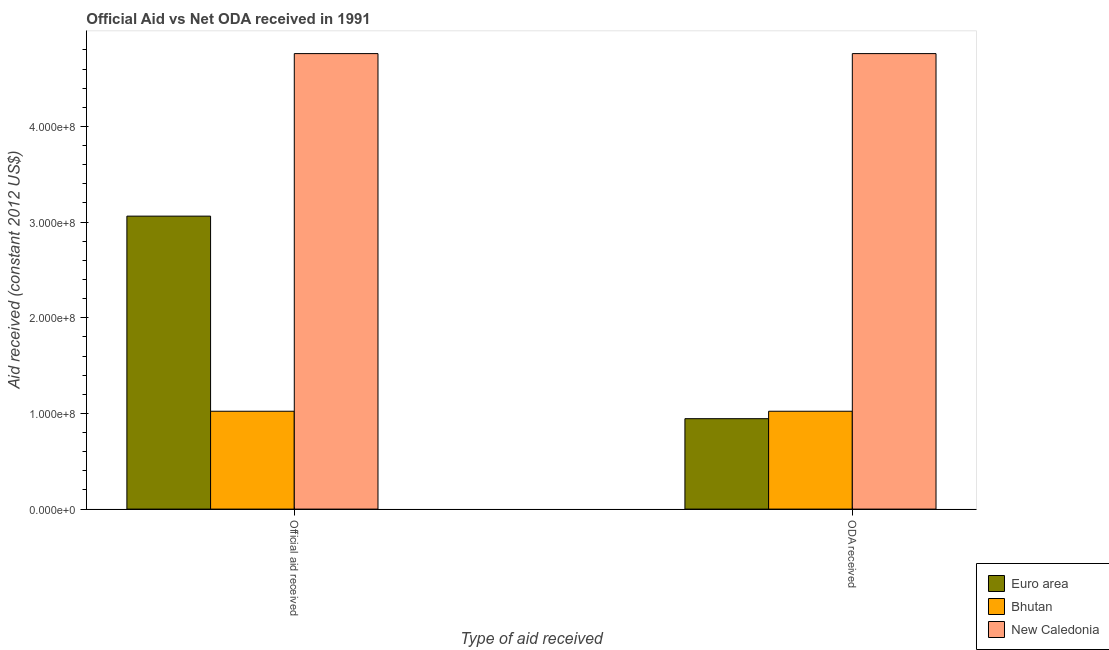How many different coloured bars are there?
Make the answer very short. 3. Are the number of bars on each tick of the X-axis equal?
Ensure brevity in your answer.  Yes. How many bars are there on the 1st tick from the left?
Your answer should be compact. 3. How many bars are there on the 2nd tick from the right?
Your answer should be very brief. 3. What is the label of the 1st group of bars from the left?
Your response must be concise. Official aid received. What is the official aid received in Bhutan?
Provide a short and direct response. 1.02e+08. Across all countries, what is the maximum oda received?
Your answer should be compact. 4.76e+08. Across all countries, what is the minimum oda received?
Keep it short and to the point. 9.45e+07. In which country was the official aid received maximum?
Give a very brief answer. New Caledonia. In which country was the official aid received minimum?
Ensure brevity in your answer.  Bhutan. What is the total oda received in the graph?
Your response must be concise. 6.73e+08. What is the difference between the oda received in New Caledonia and that in Euro area?
Offer a very short reply. 3.82e+08. What is the difference between the official aid received in Bhutan and the oda received in Euro area?
Offer a very short reply. 7.78e+06. What is the average official aid received per country?
Your answer should be compact. 2.95e+08. What is the difference between the oda received and official aid received in New Caledonia?
Keep it short and to the point. 0. In how many countries, is the official aid received greater than 140000000 US$?
Offer a terse response. 2. What is the ratio of the oda received in Bhutan to that in New Caledonia?
Offer a very short reply. 0.21. Is the official aid received in Bhutan less than that in Euro area?
Your answer should be very brief. Yes. In how many countries, is the oda received greater than the average oda received taken over all countries?
Offer a terse response. 1. What does the 2nd bar from the left in Official aid received represents?
Your answer should be compact. Bhutan. What does the 1st bar from the right in ODA received represents?
Make the answer very short. New Caledonia. Are all the bars in the graph horizontal?
Your answer should be compact. No. Are the values on the major ticks of Y-axis written in scientific E-notation?
Provide a succinct answer. Yes. How many legend labels are there?
Your answer should be very brief. 3. How are the legend labels stacked?
Give a very brief answer. Vertical. What is the title of the graph?
Offer a very short reply. Official Aid vs Net ODA received in 1991 . Does "Curacao" appear as one of the legend labels in the graph?
Offer a very short reply. No. What is the label or title of the X-axis?
Provide a short and direct response. Type of aid received. What is the label or title of the Y-axis?
Your answer should be very brief. Aid received (constant 2012 US$). What is the Aid received (constant 2012 US$) of Euro area in Official aid received?
Offer a terse response. 3.06e+08. What is the Aid received (constant 2012 US$) in Bhutan in Official aid received?
Your answer should be compact. 1.02e+08. What is the Aid received (constant 2012 US$) of New Caledonia in Official aid received?
Give a very brief answer. 4.76e+08. What is the Aid received (constant 2012 US$) of Euro area in ODA received?
Make the answer very short. 9.45e+07. What is the Aid received (constant 2012 US$) in Bhutan in ODA received?
Your answer should be compact. 1.02e+08. What is the Aid received (constant 2012 US$) of New Caledonia in ODA received?
Make the answer very short. 4.76e+08. Across all Type of aid received, what is the maximum Aid received (constant 2012 US$) of Euro area?
Your response must be concise. 3.06e+08. Across all Type of aid received, what is the maximum Aid received (constant 2012 US$) of Bhutan?
Offer a very short reply. 1.02e+08. Across all Type of aid received, what is the maximum Aid received (constant 2012 US$) in New Caledonia?
Provide a short and direct response. 4.76e+08. Across all Type of aid received, what is the minimum Aid received (constant 2012 US$) of Euro area?
Keep it short and to the point. 9.45e+07. Across all Type of aid received, what is the minimum Aid received (constant 2012 US$) in Bhutan?
Keep it short and to the point. 1.02e+08. Across all Type of aid received, what is the minimum Aid received (constant 2012 US$) of New Caledonia?
Your response must be concise. 4.76e+08. What is the total Aid received (constant 2012 US$) in Euro area in the graph?
Make the answer very short. 4.01e+08. What is the total Aid received (constant 2012 US$) in Bhutan in the graph?
Provide a short and direct response. 2.05e+08. What is the total Aid received (constant 2012 US$) in New Caledonia in the graph?
Your answer should be compact. 9.52e+08. What is the difference between the Aid received (constant 2012 US$) in Euro area in Official aid received and that in ODA received?
Make the answer very short. 2.12e+08. What is the difference between the Aid received (constant 2012 US$) in Bhutan in Official aid received and that in ODA received?
Your answer should be compact. 0. What is the difference between the Aid received (constant 2012 US$) of Euro area in Official aid received and the Aid received (constant 2012 US$) of Bhutan in ODA received?
Provide a succinct answer. 2.04e+08. What is the difference between the Aid received (constant 2012 US$) in Euro area in Official aid received and the Aid received (constant 2012 US$) in New Caledonia in ODA received?
Your response must be concise. -1.70e+08. What is the difference between the Aid received (constant 2012 US$) of Bhutan in Official aid received and the Aid received (constant 2012 US$) of New Caledonia in ODA received?
Your answer should be very brief. -3.74e+08. What is the average Aid received (constant 2012 US$) of Euro area per Type of aid received?
Your response must be concise. 2.00e+08. What is the average Aid received (constant 2012 US$) of Bhutan per Type of aid received?
Offer a very short reply. 1.02e+08. What is the average Aid received (constant 2012 US$) in New Caledonia per Type of aid received?
Make the answer very short. 4.76e+08. What is the difference between the Aid received (constant 2012 US$) of Euro area and Aid received (constant 2012 US$) of Bhutan in Official aid received?
Provide a short and direct response. 2.04e+08. What is the difference between the Aid received (constant 2012 US$) of Euro area and Aid received (constant 2012 US$) of New Caledonia in Official aid received?
Provide a short and direct response. -1.70e+08. What is the difference between the Aid received (constant 2012 US$) of Bhutan and Aid received (constant 2012 US$) of New Caledonia in Official aid received?
Make the answer very short. -3.74e+08. What is the difference between the Aid received (constant 2012 US$) of Euro area and Aid received (constant 2012 US$) of Bhutan in ODA received?
Your answer should be compact. -7.78e+06. What is the difference between the Aid received (constant 2012 US$) in Euro area and Aid received (constant 2012 US$) in New Caledonia in ODA received?
Provide a succinct answer. -3.82e+08. What is the difference between the Aid received (constant 2012 US$) of Bhutan and Aid received (constant 2012 US$) of New Caledonia in ODA received?
Give a very brief answer. -3.74e+08. What is the ratio of the Aid received (constant 2012 US$) in Euro area in Official aid received to that in ODA received?
Ensure brevity in your answer.  3.24. What is the ratio of the Aid received (constant 2012 US$) of Bhutan in Official aid received to that in ODA received?
Offer a terse response. 1. What is the ratio of the Aid received (constant 2012 US$) in New Caledonia in Official aid received to that in ODA received?
Keep it short and to the point. 1. What is the difference between the highest and the second highest Aid received (constant 2012 US$) in Euro area?
Your answer should be compact. 2.12e+08. What is the difference between the highest and the second highest Aid received (constant 2012 US$) in Bhutan?
Your answer should be compact. 0. What is the difference between the highest and the lowest Aid received (constant 2012 US$) in Euro area?
Ensure brevity in your answer.  2.12e+08. What is the difference between the highest and the lowest Aid received (constant 2012 US$) in New Caledonia?
Make the answer very short. 0. 